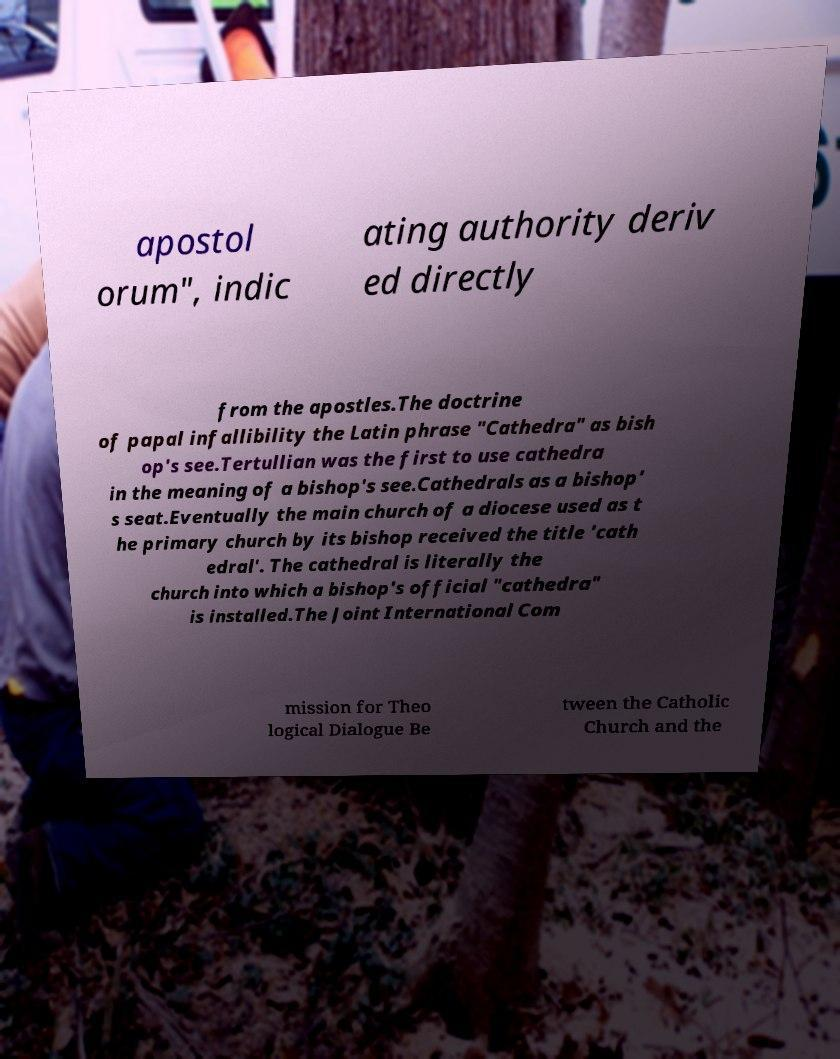Please read and relay the text visible in this image. What does it say? apostol orum", indic ating authority deriv ed directly from the apostles.The doctrine of papal infallibility the Latin phrase "Cathedra" as bish op's see.Tertullian was the first to use cathedra in the meaning of a bishop's see.Cathedrals as a bishop' s seat.Eventually the main church of a diocese used as t he primary church by its bishop received the title 'cath edral'. The cathedral is literally the church into which a bishop's official "cathedra" is installed.The Joint International Com mission for Theo logical Dialogue Be tween the Catholic Church and the 